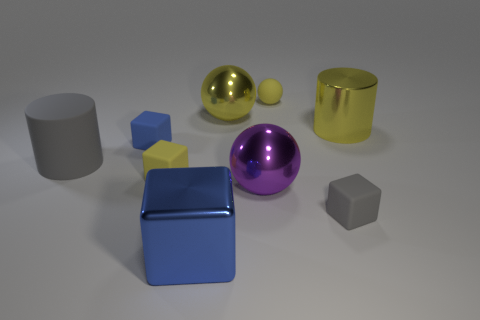Do the big object that is in front of the purple metallic ball and the tiny cube behind the large gray cylinder have the same color?
Ensure brevity in your answer.  Yes. There is a matte thing that is both behind the large purple metallic object and in front of the gray cylinder; what is its shape?
Ensure brevity in your answer.  Cube. Is there a tiny gray matte object that has the same shape as the big blue thing?
Offer a very short reply. Yes. What is the shape of the blue thing that is the same size as the purple shiny object?
Offer a very short reply. Cube. What is the material of the purple sphere?
Your answer should be very brief. Metal. There is a metallic object to the right of the small thing behind the metallic sphere behind the tiny blue object; how big is it?
Give a very brief answer. Large. There is another big ball that is the same color as the matte ball; what is its material?
Ensure brevity in your answer.  Metal. What number of metallic objects are yellow blocks or cylinders?
Ensure brevity in your answer.  1. The rubber sphere is what size?
Offer a terse response. Small. What number of things are metallic blocks or small yellow rubber things to the left of the big blue thing?
Offer a very short reply. 2. 